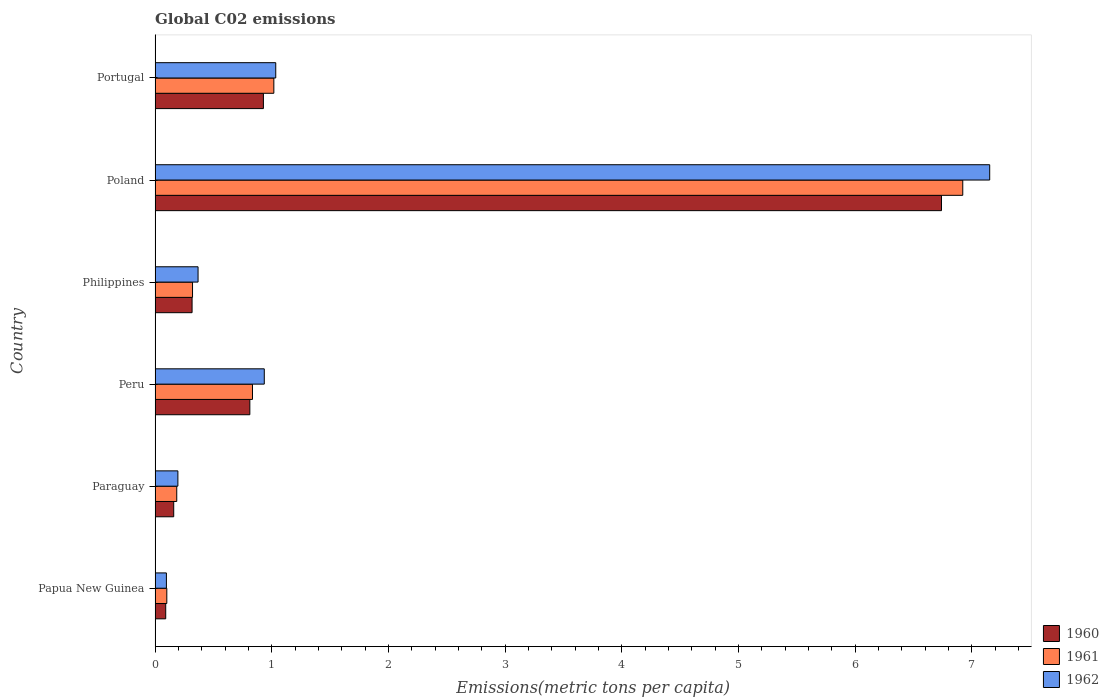Are the number of bars per tick equal to the number of legend labels?
Ensure brevity in your answer.  Yes. What is the label of the 1st group of bars from the top?
Your response must be concise. Portugal. What is the amount of CO2 emitted in in 1962 in Papua New Guinea?
Keep it short and to the point. 0.1. Across all countries, what is the maximum amount of CO2 emitted in in 1962?
Provide a short and direct response. 7.15. Across all countries, what is the minimum amount of CO2 emitted in in 1960?
Your answer should be very brief. 0.09. In which country was the amount of CO2 emitted in in 1962 maximum?
Your response must be concise. Poland. In which country was the amount of CO2 emitted in in 1960 minimum?
Ensure brevity in your answer.  Papua New Guinea. What is the total amount of CO2 emitted in in 1960 in the graph?
Offer a terse response. 9.05. What is the difference between the amount of CO2 emitted in in 1961 in Papua New Guinea and that in Philippines?
Offer a terse response. -0.22. What is the difference between the amount of CO2 emitted in in 1961 in Papua New Guinea and the amount of CO2 emitted in in 1960 in Portugal?
Provide a short and direct response. -0.83. What is the average amount of CO2 emitted in in 1962 per country?
Your response must be concise. 1.63. What is the difference between the amount of CO2 emitted in in 1960 and amount of CO2 emitted in in 1961 in Portugal?
Provide a succinct answer. -0.09. In how many countries, is the amount of CO2 emitted in in 1960 greater than 5.4 metric tons per capita?
Keep it short and to the point. 1. What is the ratio of the amount of CO2 emitted in in 1960 in Paraguay to that in Portugal?
Make the answer very short. 0.17. What is the difference between the highest and the second highest amount of CO2 emitted in in 1961?
Give a very brief answer. 5.9. What is the difference between the highest and the lowest amount of CO2 emitted in in 1962?
Provide a succinct answer. 7.06. In how many countries, is the amount of CO2 emitted in in 1961 greater than the average amount of CO2 emitted in in 1961 taken over all countries?
Offer a terse response. 1. What does the 3rd bar from the bottom in Peru represents?
Make the answer very short. 1962. Is it the case that in every country, the sum of the amount of CO2 emitted in in 1961 and amount of CO2 emitted in in 1962 is greater than the amount of CO2 emitted in in 1960?
Give a very brief answer. Yes. Are all the bars in the graph horizontal?
Keep it short and to the point. Yes. What is the difference between two consecutive major ticks on the X-axis?
Ensure brevity in your answer.  1. Does the graph contain grids?
Offer a very short reply. No. How many legend labels are there?
Provide a succinct answer. 3. What is the title of the graph?
Your answer should be compact. Global C02 emissions. Does "2013" appear as one of the legend labels in the graph?
Offer a terse response. No. What is the label or title of the X-axis?
Give a very brief answer. Emissions(metric tons per capita). What is the label or title of the Y-axis?
Make the answer very short. Country. What is the Emissions(metric tons per capita) of 1960 in Papua New Guinea?
Provide a succinct answer. 0.09. What is the Emissions(metric tons per capita) of 1961 in Papua New Guinea?
Provide a short and direct response. 0.1. What is the Emissions(metric tons per capita) in 1962 in Papua New Guinea?
Offer a very short reply. 0.1. What is the Emissions(metric tons per capita) in 1960 in Paraguay?
Provide a short and direct response. 0.16. What is the Emissions(metric tons per capita) of 1961 in Paraguay?
Offer a very short reply. 0.19. What is the Emissions(metric tons per capita) of 1962 in Paraguay?
Give a very brief answer. 0.2. What is the Emissions(metric tons per capita) in 1960 in Peru?
Provide a short and direct response. 0.81. What is the Emissions(metric tons per capita) in 1961 in Peru?
Your answer should be very brief. 0.84. What is the Emissions(metric tons per capita) in 1962 in Peru?
Your answer should be very brief. 0.94. What is the Emissions(metric tons per capita) of 1960 in Philippines?
Your response must be concise. 0.32. What is the Emissions(metric tons per capita) of 1961 in Philippines?
Your answer should be very brief. 0.32. What is the Emissions(metric tons per capita) in 1962 in Philippines?
Ensure brevity in your answer.  0.37. What is the Emissions(metric tons per capita) of 1960 in Poland?
Your answer should be very brief. 6.74. What is the Emissions(metric tons per capita) in 1961 in Poland?
Your answer should be very brief. 6.92. What is the Emissions(metric tons per capita) of 1962 in Poland?
Offer a very short reply. 7.15. What is the Emissions(metric tons per capita) in 1960 in Portugal?
Provide a succinct answer. 0.93. What is the Emissions(metric tons per capita) of 1961 in Portugal?
Give a very brief answer. 1.02. What is the Emissions(metric tons per capita) in 1962 in Portugal?
Offer a very short reply. 1.03. Across all countries, what is the maximum Emissions(metric tons per capita) of 1960?
Keep it short and to the point. 6.74. Across all countries, what is the maximum Emissions(metric tons per capita) in 1961?
Your response must be concise. 6.92. Across all countries, what is the maximum Emissions(metric tons per capita) of 1962?
Keep it short and to the point. 7.15. Across all countries, what is the minimum Emissions(metric tons per capita) in 1960?
Ensure brevity in your answer.  0.09. Across all countries, what is the minimum Emissions(metric tons per capita) of 1961?
Provide a short and direct response. 0.1. Across all countries, what is the minimum Emissions(metric tons per capita) of 1962?
Your answer should be compact. 0.1. What is the total Emissions(metric tons per capita) of 1960 in the graph?
Offer a very short reply. 9.05. What is the total Emissions(metric tons per capita) in 1961 in the graph?
Provide a short and direct response. 9.38. What is the total Emissions(metric tons per capita) of 1962 in the graph?
Give a very brief answer. 9.79. What is the difference between the Emissions(metric tons per capita) in 1960 in Papua New Guinea and that in Paraguay?
Make the answer very short. -0.07. What is the difference between the Emissions(metric tons per capita) of 1961 in Papua New Guinea and that in Paraguay?
Your answer should be very brief. -0.09. What is the difference between the Emissions(metric tons per capita) in 1962 in Papua New Guinea and that in Paraguay?
Offer a very short reply. -0.1. What is the difference between the Emissions(metric tons per capita) of 1960 in Papua New Guinea and that in Peru?
Offer a very short reply. -0.72. What is the difference between the Emissions(metric tons per capita) in 1961 in Papua New Guinea and that in Peru?
Make the answer very short. -0.73. What is the difference between the Emissions(metric tons per capita) in 1962 in Papua New Guinea and that in Peru?
Keep it short and to the point. -0.84. What is the difference between the Emissions(metric tons per capita) in 1960 in Papua New Guinea and that in Philippines?
Provide a succinct answer. -0.23. What is the difference between the Emissions(metric tons per capita) in 1961 in Papua New Guinea and that in Philippines?
Your answer should be very brief. -0.22. What is the difference between the Emissions(metric tons per capita) of 1962 in Papua New Guinea and that in Philippines?
Make the answer very short. -0.27. What is the difference between the Emissions(metric tons per capita) in 1960 in Papua New Guinea and that in Poland?
Provide a succinct answer. -6.65. What is the difference between the Emissions(metric tons per capita) in 1961 in Papua New Guinea and that in Poland?
Make the answer very short. -6.82. What is the difference between the Emissions(metric tons per capita) of 1962 in Papua New Guinea and that in Poland?
Your answer should be very brief. -7.06. What is the difference between the Emissions(metric tons per capita) of 1960 in Papua New Guinea and that in Portugal?
Make the answer very short. -0.84. What is the difference between the Emissions(metric tons per capita) of 1961 in Papua New Guinea and that in Portugal?
Your response must be concise. -0.92. What is the difference between the Emissions(metric tons per capita) of 1962 in Papua New Guinea and that in Portugal?
Your answer should be compact. -0.94. What is the difference between the Emissions(metric tons per capita) in 1960 in Paraguay and that in Peru?
Offer a terse response. -0.65. What is the difference between the Emissions(metric tons per capita) in 1961 in Paraguay and that in Peru?
Offer a terse response. -0.65. What is the difference between the Emissions(metric tons per capita) in 1962 in Paraguay and that in Peru?
Make the answer very short. -0.74. What is the difference between the Emissions(metric tons per capita) of 1960 in Paraguay and that in Philippines?
Your answer should be compact. -0.16. What is the difference between the Emissions(metric tons per capita) in 1961 in Paraguay and that in Philippines?
Your response must be concise. -0.14. What is the difference between the Emissions(metric tons per capita) of 1962 in Paraguay and that in Philippines?
Your answer should be very brief. -0.17. What is the difference between the Emissions(metric tons per capita) of 1960 in Paraguay and that in Poland?
Keep it short and to the point. -6.58. What is the difference between the Emissions(metric tons per capita) in 1961 in Paraguay and that in Poland?
Keep it short and to the point. -6.74. What is the difference between the Emissions(metric tons per capita) in 1962 in Paraguay and that in Poland?
Offer a very short reply. -6.96. What is the difference between the Emissions(metric tons per capita) in 1960 in Paraguay and that in Portugal?
Offer a terse response. -0.77. What is the difference between the Emissions(metric tons per capita) of 1961 in Paraguay and that in Portugal?
Keep it short and to the point. -0.83. What is the difference between the Emissions(metric tons per capita) of 1962 in Paraguay and that in Portugal?
Your response must be concise. -0.84. What is the difference between the Emissions(metric tons per capita) of 1960 in Peru and that in Philippines?
Your answer should be very brief. 0.5. What is the difference between the Emissions(metric tons per capita) of 1961 in Peru and that in Philippines?
Provide a succinct answer. 0.51. What is the difference between the Emissions(metric tons per capita) of 1962 in Peru and that in Philippines?
Ensure brevity in your answer.  0.57. What is the difference between the Emissions(metric tons per capita) in 1960 in Peru and that in Poland?
Ensure brevity in your answer.  -5.93. What is the difference between the Emissions(metric tons per capita) in 1961 in Peru and that in Poland?
Ensure brevity in your answer.  -6.09. What is the difference between the Emissions(metric tons per capita) in 1962 in Peru and that in Poland?
Offer a very short reply. -6.22. What is the difference between the Emissions(metric tons per capita) in 1960 in Peru and that in Portugal?
Your answer should be compact. -0.12. What is the difference between the Emissions(metric tons per capita) in 1961 in Peru and that in Portugal?
Your answer should be compact. -0.18. What is the difference between the Emissions(metric tons per capita) of 1962 in Peru and that in Portugal?
Provide a succinct answer. -0.1. What is the difference between the Emissions(metric tons per capita) of 1960 in Philippines and that in Poland?
Provide a short and direct response. -6.42. What is the difference between the Emissions(metric tons per capita) of 1961 in Philippines and that in Poland?
Provide a short and direct response. -6.6. What is the difference between the Emissions(metric tons per capita) of 1962 in Philippines and that in Poland?
Provide a succinct answer. -6.79. What is the difference between the Emissions(metric tons per capita) of 1960 in Philippines and that in Portugal?
Keep it short and to the point. -0.61. What is the difference between the Emissions(metric tons per capita) of 1961 in Philippines and that in Portugal?
Make the answer very short. -0.7. What is the difference between the Emissions(metric tons per capita) in 1962 in Philippines and that in Portugal?
Ensure brevity in your answer.  -0.67. What is the difference between the Emissions(metric tons per capita) of 1960 in Poland and that in Portugal?
Your response must be concise. 5.81. What is the difference between the Emissions(metric tons per capita) in 1961 in Poland and that in Portugal?
Ensure brevity in your answer.  5.9. What is the difference between the Emissions(metric tons per capita) in 1962 in Poland and that in Portugal?
Your answer should be compact. 6.12. What is the difference between the Emissions(metric tons per capita) in 1960 in Papua New Guinea and the Emissions(metric tons per capita) in 1961 in Paraguay?
Your answer should be very brief. -0.09. What is the difference between the Emissions(metric tons per capita) in 1960 in Papua New Guinea and the Emissions(metric tons per capita) in 1962 in Paraguay?
Your answer should be very brief. -0.1. What is the difference between the Emissions(metric tons per capita) of 1961 in Papua New Guinea and the Emissions(metric tons per capita) of 1962 in Paraguay?
Offer a terse response. -0.09. What is the difference between the Emissions(metric tons per capita) of 1960 in Papua New Guinea and the Emissions(metric tons per capita) of 1961 in Peru?
Offer a very short reply. -0.74. What is the difference between the Emissions(metric tons per capita) of 1960 in Papua New Guinea and the Emissions(metric tons per capita) of 1962 in Peru?
Your response must be concise. -0.84. What is the difference between the Emissions(metric tons per capita) in 1961 in Papua New Guinea and the Emissions(metric tons per capita) in 1962 in Peru?
Provide a succinct answer. -0.84. What is the difference between the Emissions(metric tons per capita) in 1960 in Papua New Guinea and the Emissions(metric tons per capita) in 1961 in Philippines?
Provide a succinct answer. -0.23. What is the difference between the Emissions(metric tons per capita) of 1960 in Papua New Guinea and the Emissions(metric tons per capita) of 1962 in Philippines?
Keep it short and to the point. -0.28. What is the difference between the Emissions(metric tons per capita) of 1961 in Papua New Guinea and the Emissions(metric tons per capita) of 1962 in Philippines?
Ensure brevity in your answer.  -0.27. What is the difference between the Emissions(metric tons per capita) in 1960 in Papua New Guinea and the Emissions(metric tons per capita) in 1961 in Poland?
Provide a short and direct response. -6.83. What is the difference between the Emissions(metric tons per capita) of 1960 in Papua New Guinea and the Emissions(metric tons per capita) of 1962 in Poland?
Give a very brief answer. -7.06. What is the difference between the Emissions(metric tons per capita) in 1961 in Papua New Guinea and the Emissions(metric tons per capita) in 1962 in Poland?
Your response must be concise. -7.05. What is the difference between the Emissions(metric tons per capita) in 1960 in Papua New Guinea and the Emissions(metric tons per capita) in 1961 in Portugal?
Your answer should be compact. -0.93. What is the difference between the Emissions(metric tons per capita) of 1960 in Papua New Guinea and the Emissions(metric tons per capita) of 1962 in Portugal?
Your response must be concise. -0.94. What is the difference between the Emissions(metric tons per capita) of 1961 in Papua New Guinea and the Emissions(metric tons per capita) of 1962 in Portugal?
Provide a succinct answer. -0.93. What is the difference between the Emissions(metric tons per capita) in 1960 in Paraguay and the Emissions(metric tons per capita) in 1961 in Peru?
Ensure brevity in your answer.  -0.68. What is the difference between the Emissions(metric tons per capita) of 1960 in Paraguay and the Emissions(metric tons per capita) of 1962 in Peru?
Your answer should be compact. -0.78. What is the difference between the Emissions(metric tons per capita) of 1961 in Paraguay and the Emissions(metric tons per capita) of 1962 in Peru?
Your answer should be compact. -0.75. What is the difference between the Emissions(metric tons per capita) in 1960 in Paraguay and the Emissions(metric tons per capita) in 1961 in Philippines?
Your answer should be compact. -0.16. What is the difference between the Emissions(metric tons per capita) of 1960 in Paraguay and the Emissions(metric tons per capita) of 1962 in Philippines?
Give a very brief answer. -0.21. What is the difference between the Emissions(metric tons per capita) in 1961 in Paraguay and the Emissions(metric tons per capita) in 1962 in Philippines?
Keep it short and to the point. -0.18. What is the difference between the Emissions(metric tons per capita) in 1960 in Paraguay and the Emissions(metric tons per capita) in 1961 in Poland?
Ensure brevity in your answer.  -6.76. What is the difference between the Emissions(metric tons per capita) of 1960 in Paraguay and the Emissions(metric tons per capita) of 1962 in Poland?
Your response must be concise. -6.99. What is the difference between the Emissions(metric tons per capita) in 1961 in Paraguay and the Emissions(metric tons per capita) in 1962 in Poland?
Your answer should be very brief. -6.97. What is the difference between the Emissions(metric tons per capita) of 1960 in Paraguay and the Emissions(metric tons per capita) of 1961 in Portugal?
Offer a very short reply. -0.86. What is the difference between the Emissions(metric tons per capita) in 1960 in Paraguay and the Emissions(metric tons per capita) in 1962 in Portugal?
Provide a succinct answer. -0.87. What is the difference between the Emissions(metric tons per capita) of 1961 in Paraguay and the Emissions(metric tons per capita) of 1962 in Portugal?
Your answer should be compact. -0.85. What is the difference between the Emissions(metric tons per capita) of 1960 in Peru and the Emissions(metric tons per capita) of 1961 in Philippines?
Offer a very short reply. 0.49. What is the difference between the Emissions(metric tons per capita) of 1960 in Peru and the Emissions(metric tons per capita) of 1962 in Philippines?
Your response must be concise. 0.44. What is the difference between the Emissions(metric tons per capita) in 1961 in Peru and the Emissions(metric tons per capita) in 1962 in Philippines?
Make the answer very short. 0.47. What is the difference between the Emissions(metric tons per capita) of 1960 in Peru and the Emissions(metric tons per capita) of 1961 in Poland?
Your answer should be very brief. -6.11. What is the difference between the Emissions(metric tons per capita) in 1960 in Peru and the Emissions(metric tons per capita) in 1962 in Poland?
Make the answer very short. -6.34. What is the difference between the Emissions(metric tons per capita) of 1961 in Peru and the Emissions(metric tons per capita) of 1962 in Poland?
Keep it short and to the point. -6.32. What is the difference between the Emissions(metric tons per capita) of 1960 in Peru and the Emissions(metric tons per capita) of 1961 in Portugal?
Offer a terse response. -0.21. What is the difference between the Emissions(metric tons per capita) in 1960 in Peru and the Emissions(metric tons per capita) in 1962 in Portugal?
Offer a terse response. -0.22. What is the difference between the Emissions(metric tons per capita) of 1961 in Peru and the Emissions(metric tons per capita) of 1962 in Portugal?
Ensure brevity in your answer.  -0.2. What is the difference between the Emissions(metric tons per capita) in 1960 in Philippines and the Emissions(metric tons per capita) in 1961 in Poland?
Give a very brief answer. -6.61. What is the difference between the Emissions(metric tons per capita) of 1960 in Philippines and the Emissions(metric tons per capita) of 1962 in Poland?
Ensure brevity in your answer.  -6.84. What is the difference between the Emissions(metric tons per capita) in 1961 in Philippines and the Emissions(metric tons per capita) in 1962 in Poland?
Keep it short and to the point. -6.83. What is the difference between the Emissions(metric tons per capita) of 1960 in Philippines and the Emissions(metric tons per capita) of 1961 in Portugal?
Ensure brevity in your answer.  -0.7. What is the difference between the Emissions(metric tons per capita) in 1960 in Philippines and the Emissions(metric tons per capita) in 1962 in Portugal?
Your answer should be very brief. -0.72. What is the difference between the Emissions(metric tons per capita) in 1961 in Philippines and the Emissions(metric tons per capita) in 1962 in Portugal?
Offer a terse response. -0.71. What is the difference between the Emissions(metric tons per capita) in 1960 in Poland and the Emissions(metric tons per capita) in 1961 in Portugal?
Keep it short and to the point. 5.72. What is the difference between the Emissions(metric tons per capita) in 1960 in Poland and the Emissions(metric tons per capita) in 1962 in Portugal?
Your answer should be very brief. 5.71. What is the difference between the Emissions(metric tons per capita) of 1961 in Poland and the Emissions(metric tons per capita) of 1962 in Portugal?
Offer a terse response. 5.89. What is the average Emissions(metric tons per capita) in 1960 per country?
Provide a succinct answer. 1.51. What is the average Emissions(metric tons per capita) of 1961 per country?
Your answer should be very brief. 1.56. What is the average Emissions(metric tons per capita) of 1962 per country?
Offer a very short reply. 1.63. What is the difference between the Emissions(metric tons per capita) in 1960 and Emissions(metric tons per capita) in 1961 in Papua New Guinea?
Ensure brevity in your answer.  -0.01. What is the difference between the Emissions(metric tons per capita) of 1960 and Emissions(metric tons per capita) of 1962 in Papua New Guinea?
Offer a very short reply. -0.01. What is the difference between the Emissions(metric tons per capita) of 1961 and Emissions(metric tons per capita) of 1962 in Papua New Guinea?
Ensure brevity in your answer.  0. What is the difference between the Emissions(metric tons per capita) of 1960 and Emissions(metric tons per capita) of 1961 in Paraguay?
Your response must be concise. -0.03. What is the difference between the Emissions(metric tons per capita) in 1960 and Emissions(metric tons per capita) in 1962 in Paraguay?
Make the answer very short. -0.04. What is the difference between the Emissions(metric tons per capita) of 1961 and Emissions(metric tons per capita) of 1962 in Paraguay?
Offer a terse response. -0.01. What is the difference between the Emissions(metric tons per capita) in 1960 and Emissions(metric tons per capita) in 1961 in Peru?
Your answer should be very brief. -0.02. What is the difference between the Emissions(metric tons per capita) of 1960 and Emissions(metric tons per capita) of 1962 in Peru?
Make the answer very short. -0.12. What is the difference between the Emissions(metric tons per capita) of 1961 and Emissions(metric tons per capita) of 1962 in Peru?
Ensure brevity in your answer.  -0.1. What is the difference between the Emissions(metric tons per capita) in 1960 and Emissions(metric tons per capita) in 1961 in Philippines?
Make the answer very short. -0. What is the difference between the Emissions(metric tons per capita) in 1960 and Emissions(metric tons per capita) in 1962 in Philippines?
Your response must be concise. -0.05. What is the difference between the Emissions(metric tons per capita) in 1961 and Emissions(metric tons per capita) in 1962 in Philippines?
Offer a very short reply. -0.05. What is the difference between the Emissions(metric tons per capita) in 1960 and Emissions(metric tons per capita) in 1961 in Poland?
Your answer should be compact. -0.18. What is the difference between the Emissions(metric tons per capita) of 1960 and Emissions(metric tons per capita) of 1962 in Poland?
Give a very brief answer. -0.41. What is the difference between the Emissions(metric tons per capita) of 1961 and Emissions(metric tons per capita) of 1962 in Poland?
Keep it short and to the point. -0.23. What is the difference between the Emissions(metric tons per capita) of 1960 and Emissions(metric tons per capita) of 1961 in Portugal?
Your response must be concise. -0.09. What is the difference between the Emissions(metric tons per capita) in 1960 and Emissions(metric tons per capita) in 1962 in Portugal?
Offer a terse response. -0.11. What is the difference between the Emissions(metric tons per capita) in 1961 and Emissions(metric tons per capita) in 1962 in Portugal?
Offer a terse response. -0.02. What is the ratio of the Emissions(metric tons per capita) in 1960 in Papua New Guinea to that in Paraguay?
Your answer should be very brief. 0.57. What is the ratio of the Emissions(metric tons per capita) in 1961 in Papua New Guinea to that in Paraguay?
Provide a succinct answer. 0.54. What is the ratio of the Emissions(metric tons per capita) of 1962 in Papua New Guinea to that in Paraguay?
Offer a very short reply. 0.5. What is the ratio of the Emissions(metric tons per capita) in 1960 in Papua New Guinea to that in Peru?
Provide a succinct answer. 0.11. What is the ratio of the Emissions(metric tons per capita) of 1961 in Papua New Guinea to that in Peru?
Ensure brevity in your answer.  0.12. What is the ratio of the Emissions(metric tons per capita) in 1962 in Papua New Guinea to that in Peru?
Your response must be concise. 0.1. What is the ratio of the Emissions(metric tons per capita) in 1960 in Papua New Guinea to that in Philippines?
Ensure brevity in your answer.  0.29. What is the ratio of the Emissions(metric tons per capita) in 1961 in Papua New Guinea to that in Philippines?
Provide a short and direct response. 0.31. What is the ratio of the Emissions(metric tons per capita) of 1962 in Papua New Guinea to that in Philippines?
Your answer should be very brief. 0.26. What is the ratio of the Emissions(metric tons per capita) of 1960 in Papua New Guinea to that in Poland?
Keep it short and to the point. 0.01. What is the ratio of the Emissions(metric tons per capita) in 1961 in Papua New Guinea to that in Poland?
Ensure brevity in your answer.  0.01. What is the ratio of the Emissions(metric tons per capita) of 1962 in Papua New Guinea to that in Poland?
Provide a short and direct response. 0.01. What is the ratio of the Emissions(metric tons per capita) of 1960 in Papua New Guinea to that in Portugal?
Give a very brief answer. 0.1. What is the ratio of the Emissions(metric tons per capita) of 1961 in Papua New Guinea to that in Portugal?
Your answer should be compact. 0.1. What is the ratio of the Emissions(metric tons per capita) in 1962 in Papua New Guinea to that in Portugal?
Make the answer very short. 0.09. What is the ratio of the Emissions(metric tons per capita) of 1960 in Paraguay to that in Peru?
Provide a succinct answer. 0.2. What is the ratio of the Emissions(metric tons per capita) of 1961 in Paraguay to that in Peru?
Your answer should be very brief. 0.22. What is the ratio of the Emissions(metric tons per capita) of 1962 in Paraguay to that in Peru?
Ensure brevity in your answer.  0.21. What is the ratio of the Emissions(metric tons per capita) in 1960 in Paraguay to that in Philippines?
Your answer should be very brief. 0.5. What is the ratio of the Emissions(metric tons per capita) of 1961 in Paraguay to that in Philippines?
Make the answer very short. 0.58. What is the ratio of the Emissions(metric tons per capita) in 1962 in Paraguay to that in Philippines?
Provide a succinct answer. 0.53. What is the ratio of the Emissions(metric tons per capita) in 1960 in Paraguay to that in Poland?
Ensure brevity in your answer.  0.02. What is the ratio of the Emissions(metric tons per capita) of 1961 in Paraguay to that in Poland?
Provide a short and direct response. 0.03. What is the ratio of the Emissions(metric tons per capita) of 1962 in Paraguay to that in Poland?
Provide a short and direct response. 0.03. What is the ratio of the Emissions(metric tons per capita) in 1960 in Paraguay to that in Portugal?
Offer a very short reply. 0.17. What is the ratio of the Emissions(metric tons per capita) of 1961 in Paraguay to that in Portugal?
Give a very brief answer. 0.18. What is the ratio of the Emissions(metric tons per capita) in 1962 in Paraguay to that in Portugal?
Keep it short and to the point. 0.19. What is the ratio of the Emissions(metric tons per capita) in 1960 in Peru to that in Philippines?
Your answer should be compact. 2.56. What is the ratio of the Emissions(metric tons per capita) of 1961 in Peru to that in Philippines?
Your answer should be very brief. 2.6. What is the ratio of the Emissions(metric tons per capita) in 1962 in Peru to that in Philippines?
Your answer should be compact. 2.54. What is the ratio of the Emissions(metric tons per capita) of 1960 in Peru to that in Poland?
Offer a very short reply. 0.12. What is the ratio of the Emissions(metric tons per capita) in 1961 in Peru to that in Poland?
Keep it short and to the point. 0.12. What is the ratio of the Emissions(metric tons per capita) in 1962 in Peru to that in Poland?
Make the answer very short. 0.13. What is the ratio of the Emissions(metric tons per capita) of 1960 in Peru to that in Portugal?
Your answer should be very brief. 0.87. What is the ratio of the Emissions(metric tons per capita) in 1961 in Peru to that in Portugal?
Your response must be concise. 0.82. What is the ratio of the Emissions(metric tons per capita) of 1962 in Peru to that in Portugal?
Provide a succinct answer. 0.91. What is the ratio of the Emissions(metric tons per capita) in 1960 in Philippines to that in Poland?
Make the answer very short. 0.05. What is the ratio of the Emissions(metric tons per capita) in 1961 in Philippines to that in Poland?
Offer a very short reply. 0.05. What is the ratio of the Emissions(metric tons per capita) of 1962 in Philippines to that in Poland?
Your answer should be compact. 0.05. What is the ratio of the Emissions(metric tons per capita) in 1960 in Philippines to that in Portugal?
Your answer should be compact. 0.34. What is the ratio of the Emissions(metric tons per capita) of 1961 in Philippines to that in Portugal?
Ensure brevity in your answer.  0.32. What is the ratio of the Emissions(metric tons per capita) in 1962 in Philippines to that in Portugal?
Keep it short and to the point. 0.36. What is the ratio of the Emissions(metric tons per capita) in 1960 in Poland to that in Portugal?
Make the answer very short. 7.26. What is the ratio of the Emissions(metric tons per capita) in 1961 in Poland to that in Portugal?
Provide a short and direct response. 6.8. What is the ratio of the Emissions(metric tons per capita) of 1962 in Poland to that in Portugal?
Provide a succinct answer. 6.92. What is the difference between the highest and the second highest Emissions(metric tons per capita) of 1960?
Your answer should be very brief. 5.81. What is the difference between the highest and the second highest Emissions(metric tons per capita) of 1961?
Your response must be concise. 5.9. What is the difference between the highest and the second highest Emissions(metric tons per capita) in 1962?
Give a very brief answer. 6.12. What is the difference between the highest and the lowest Emissions(metric tons per capita) in 1960?
Offer a very short reply. 6.65. What is the difference between the highest and the lowest Emissions(metric tons per capita) of 1961?
Ensure brevity in your answer.  6.82. What is the difference between the highest and the lowest Emissions(metric tons per capita) of 1962?
Your answer should be compact. 7.06. 